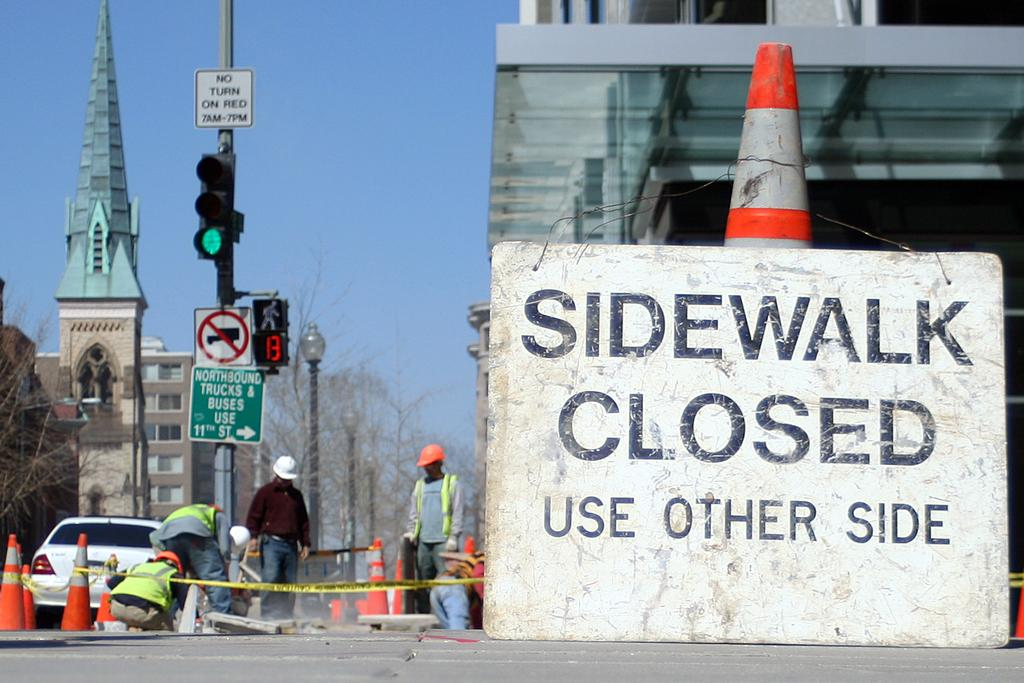<image>
Offer a succinct explanation of the picture presented. A construction with a sign that says sidewalk closed. 